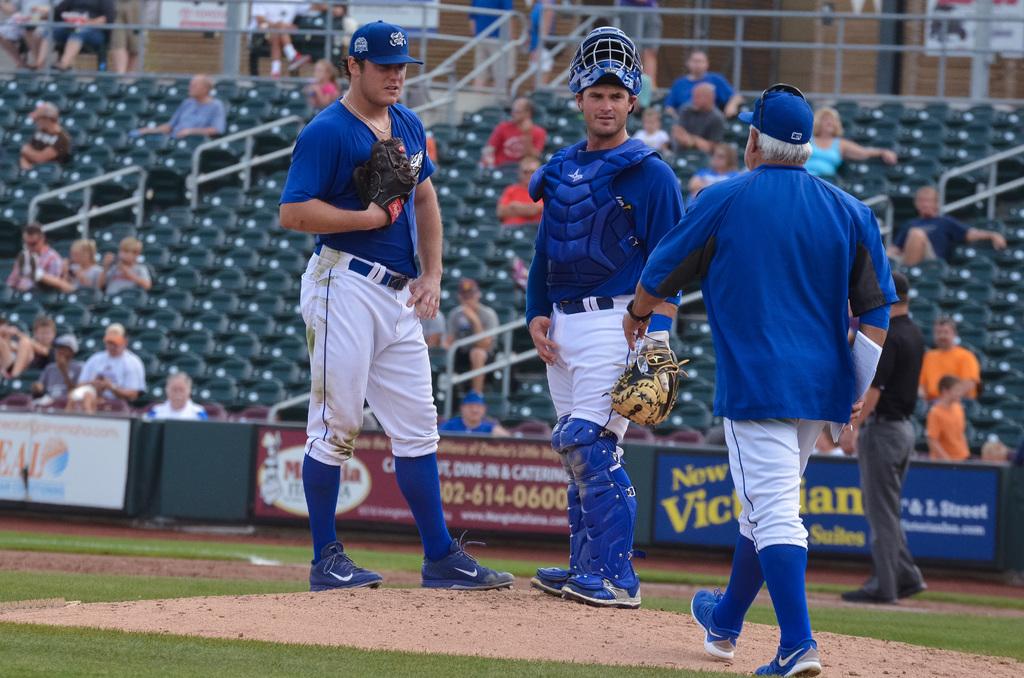Is 614 on the red sign visable?
Offer a terse response. Yes. 